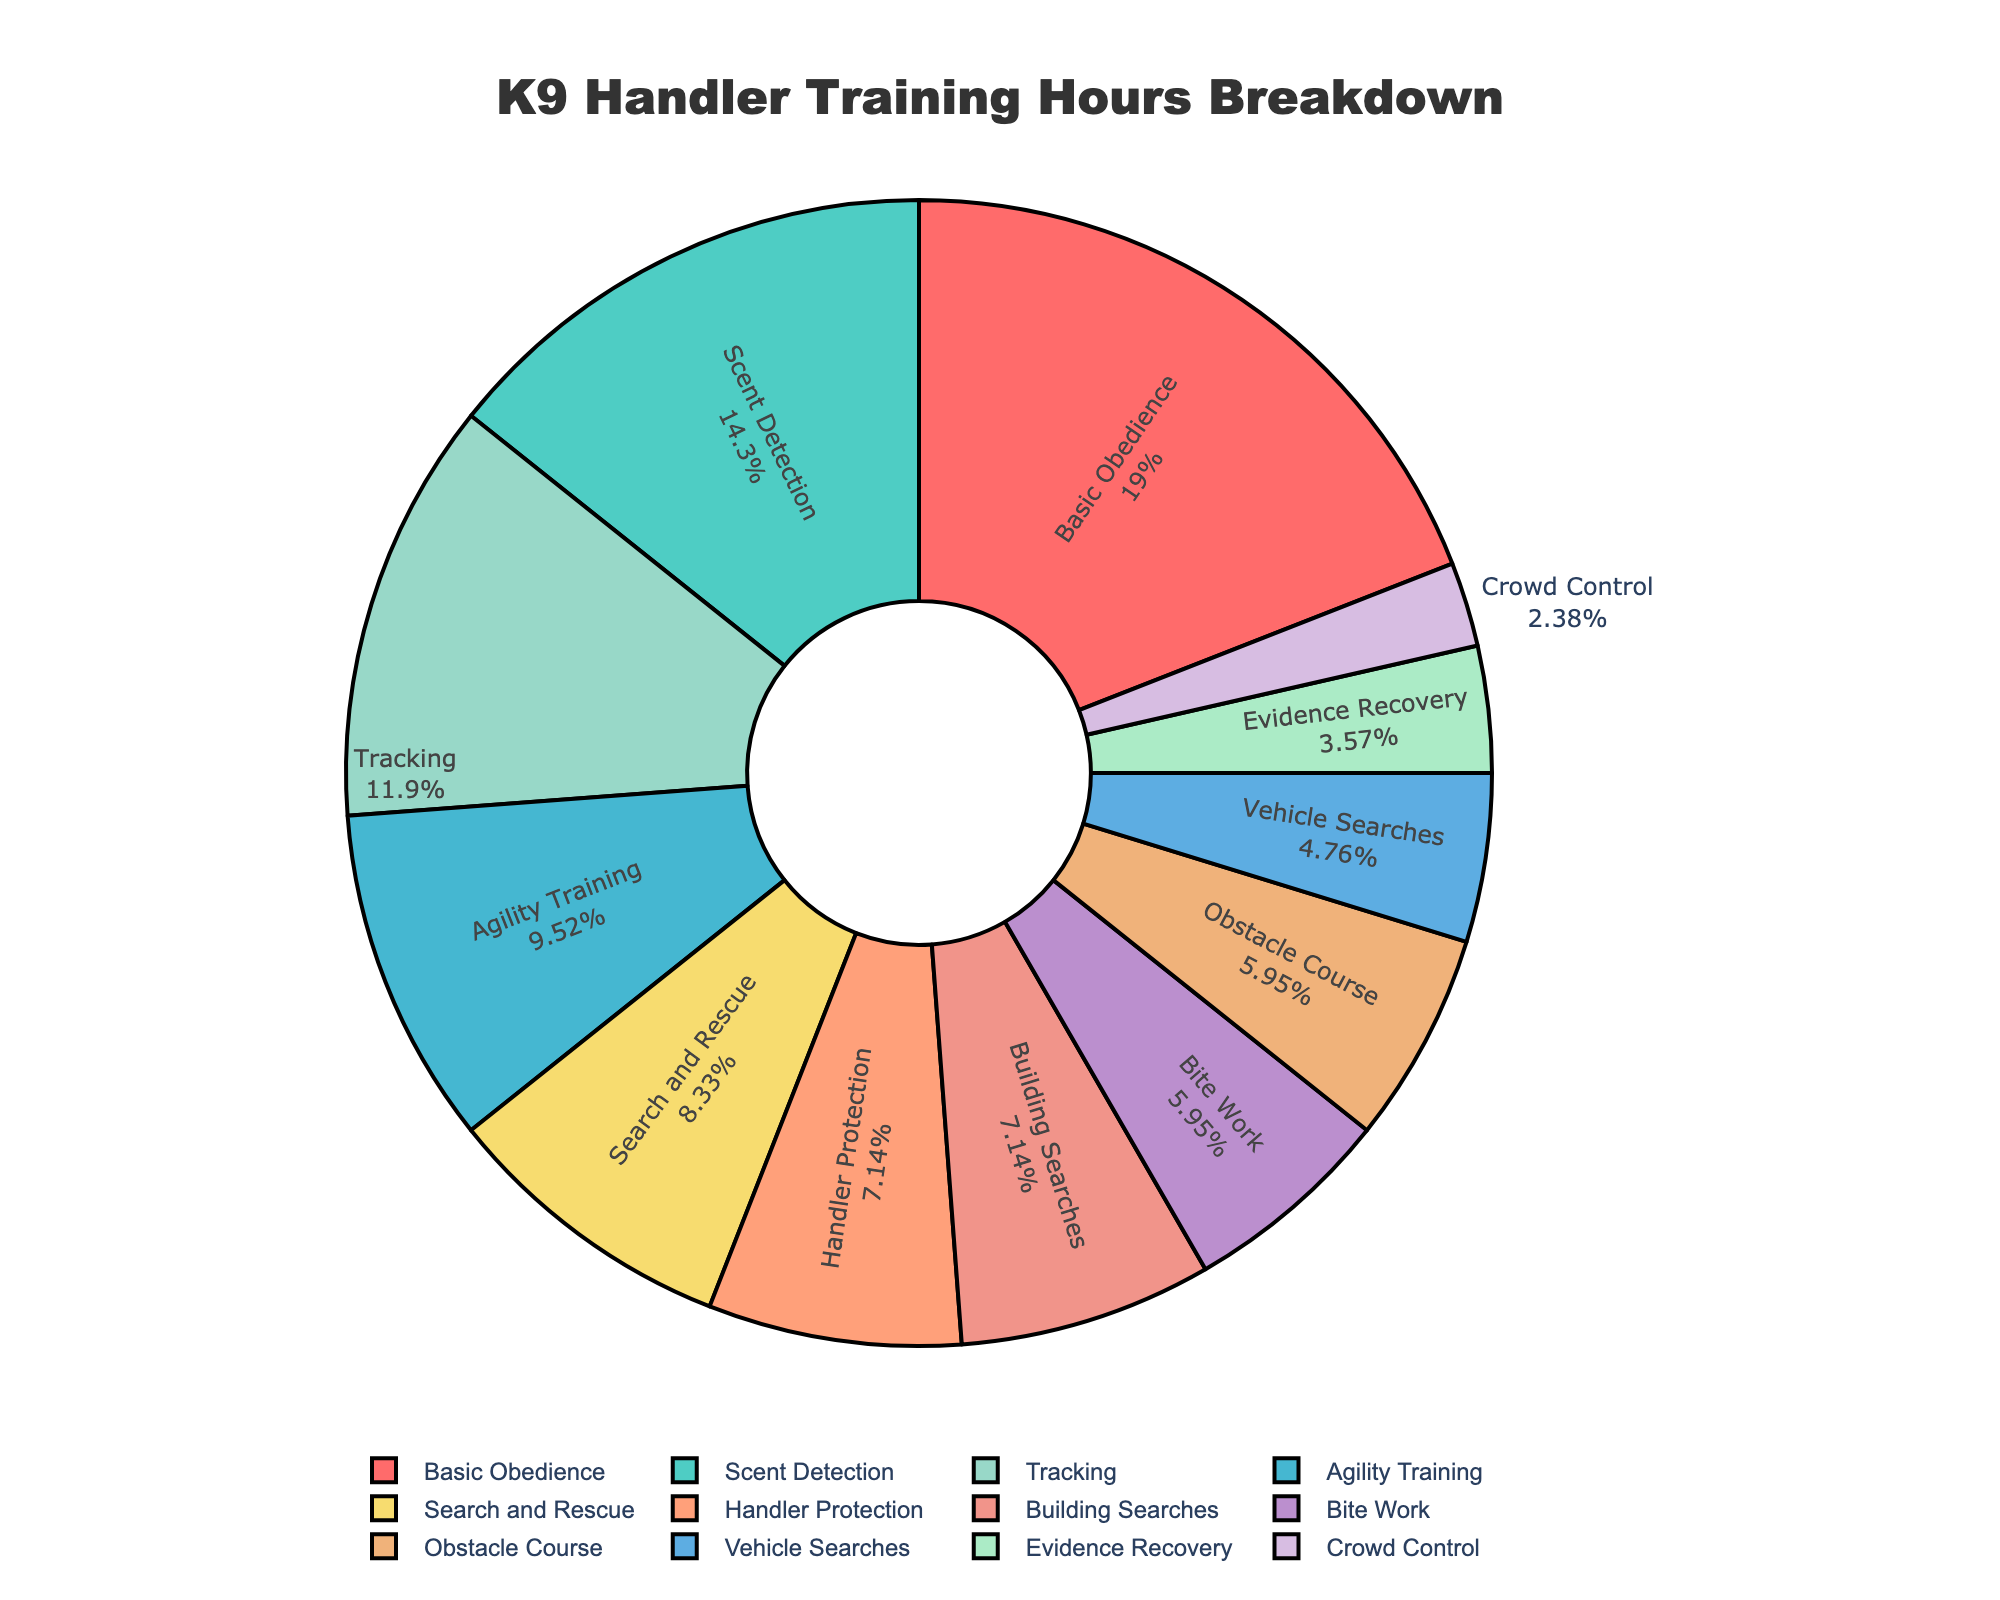What skill has the highest training hours? The figure shows that Basic Obedience has the highest number of training hours dedicated to it, indicated by the largest section in the pie chart.
Answer: Basic Obedience Which skill is allocated fewer hours: Scent Detection or Building Searches? By comparing the sizes of the pie chart sections, Scent Detection has 60 hours, whereas Building Searches has 30 hours. Therefore, Building Searches has fewer hours.
Answer: Building Searches How many total hours are dedicated to Training Skills that involve searching (Vehicle Searches, Building Searches, Search, and Rescue)? Vehicle Searches (20) + Building Searches (30) + Search and Rescue (35) = 85 hours. Summing these values gives the total number of hours for search-related skills.
Answer: 85 Which skill has a smaller share: Bite Work or Evidence Recovery? By comparing the section sizes, Bite Work has 25 hours, whereas Evidence Recovery has 15 hours. Therefore, Evidence Recovery has a smaller share.
Answer: Evidence Recovery How much more time is spent on Basic Obedience compared to Tracking? The pie chart shows Basic Obedience having 80 hours and Tracking at 50 hours. The difference is 80 - 50 = 30 hours.
Answer: 30 hours What percentage of the total training hours is dedicated to Scent Detection? In the pie chart, the percentage for Scent Detection can be read directly from the label, which shows both the skill and its percentage.
Answer: Not specified, but can be read directly from the chart What skills combined have the same number of hours as Agility Training? Agility Training has 40 hours. Building Searches (30) + Evidence Recovery (10) = 40 hours. So, Building Searches and Evidence Recovery together have the same number of hours as Agility Training.
Answer: Building Searches and Evidence Recovery Which skills together make up more than half of the total training hours? Adding hours of the highest ones until they exceed half of the total hours: Basic Obedience (80) + Scent Detection (60) + Tracking (50) = 190. The total is more than half (sum these hours then compare to total).
Answer: Basic Obedience, Scent Detection, and Tracking 